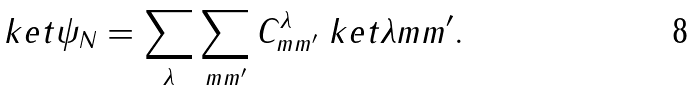Convert formula to latex. <formula><loc_0><loc_0><loc_500><loc_500>\ k e t { \psi _ { N } } = \sum _ { \lambda } \sum _ { m m ^ { \prime } } C ^ { \lambda } _ { m m ^ { \prime } } \ k e t { \lambda m m ^ { \prime } } .</formula> 